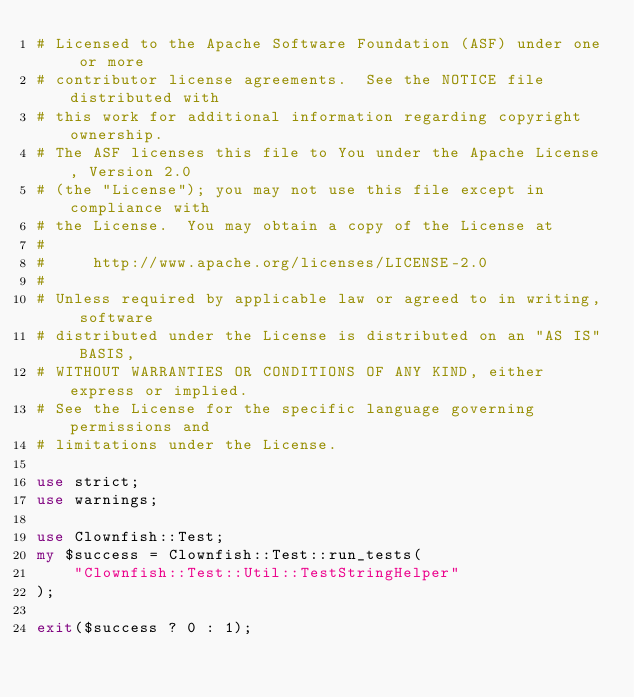Convert code to text. <code><loc_0><loc_0><loc_500><loc_500><_Perl_># Licensed to the Apache Software Foundation (ASF) under one or more
# contributor license agreements.  See the NOTICE file distributed with
# this work for additional information regarding copyright ownership.
# The ASF licenses this file to You under the Apache License, Version 2.0
# (the "License"); you may not use this file except in compliance with
# the License.  You may obtain a copy of the License at
#
#     http://www.apache.org/licenses/LICENSE-2.0
#
# Unless required by applicable law or agreed to in writing, software
# distributed under the License is distributed on an "AS IS" BASIS,
# WITHOUT WARRANTIES OR CONDITIONS OF ANY KIND, either express or implied.
# See the License for the specific language governing permissions and
# limitations under the License.

use strict;
use warnings;

use Clownfish::Test;
my $success = Clownfish::Test::run_tests(
    "Clownfish::Test::Util::TestStringHelper"
);

exit($success ? 0 : 1);

</code> 